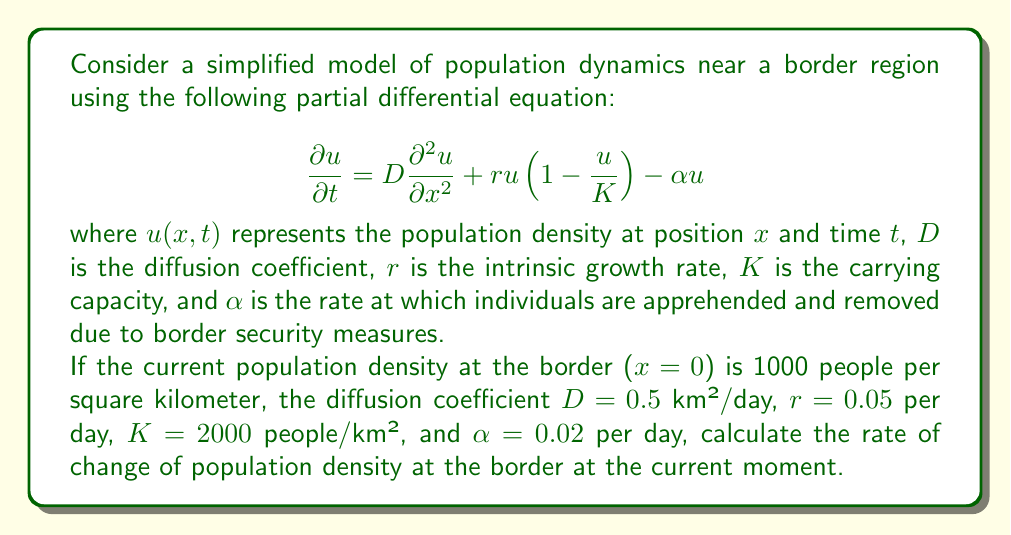Give your solution to this math problem. To solve this problem, we need to evaluate the right-hand side of the PDE at $x=0$ and $t=0$ (current moment), given the information provided.

1) First, let's identify the known values:
   $u(0,0) = 1000$ people/km²
   $D = 0.5$ km²/day
   $r = 0.05$ per day
   $K = 2000$ people/km²
   $\alpha = 0.02$ per day

2) The PDE is:
   $$\frac{\partial u}{\partial t} = D\frac{\partial^2 u}{\partial x^2} + ru(1-\frac{u}{K}) - \alpha u$$

3) We need to evaluate each term:

   a) For the diffusion term $D\frac{\partial^2 u}{\partial x^2}$, we don't have information about the spatial distribution of $u$. Therefore, we'll assume this term is zero at the border.

   b) For the logistic growth term $ru(1-\frac{u}{K})$:
      $$0.05 \cdot 1000 \cdot (1-\frac{1000}{2000}) = 25$$ people/km²/day

   c) For the removal term $-\alpha u$:
      $$-0.02 \cdot 1000 = -20$$ people/km²/day

4) Summing up all terms:
   $$\frac{\partial u}{\partial t} = 0 + 25 - 20 = 5$$ people/km²/day

Therefore, the rate of change of population density at the border at the current moment is 5 people/km²/day.
Answer: 5 people/km²/day 